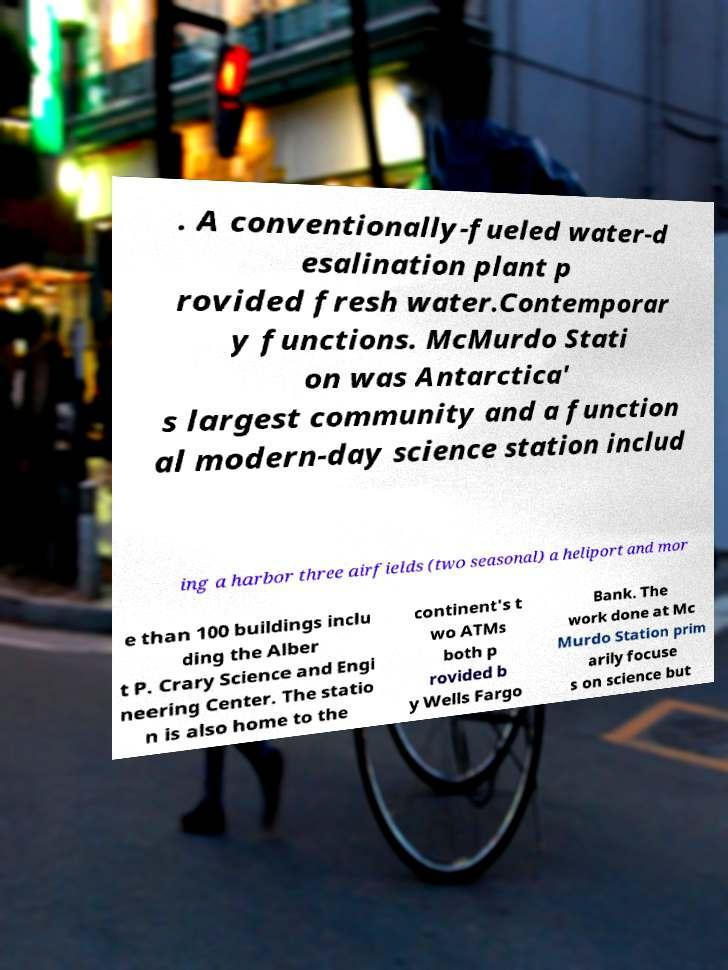Could you assist in decoding the text presented in this image and type it out clearly? . A conventionally-fueled water-d esalination plant p rovided fresh water.Contemporar y functions. McMurdo Stati on was Antarctica' s largest community and a function al modern-day science station includ ing a harbor three airfields (two seasonal) a heliport and mor e than 100 buildings inclu ding the Alber t P. Crary Science and Engi neering Center. The statio n is also home to the continent's t wo ATMs both p rovided b y Wells Fargo Bank. The work done at Mc Murdo Station prim arily focuse s on science but 